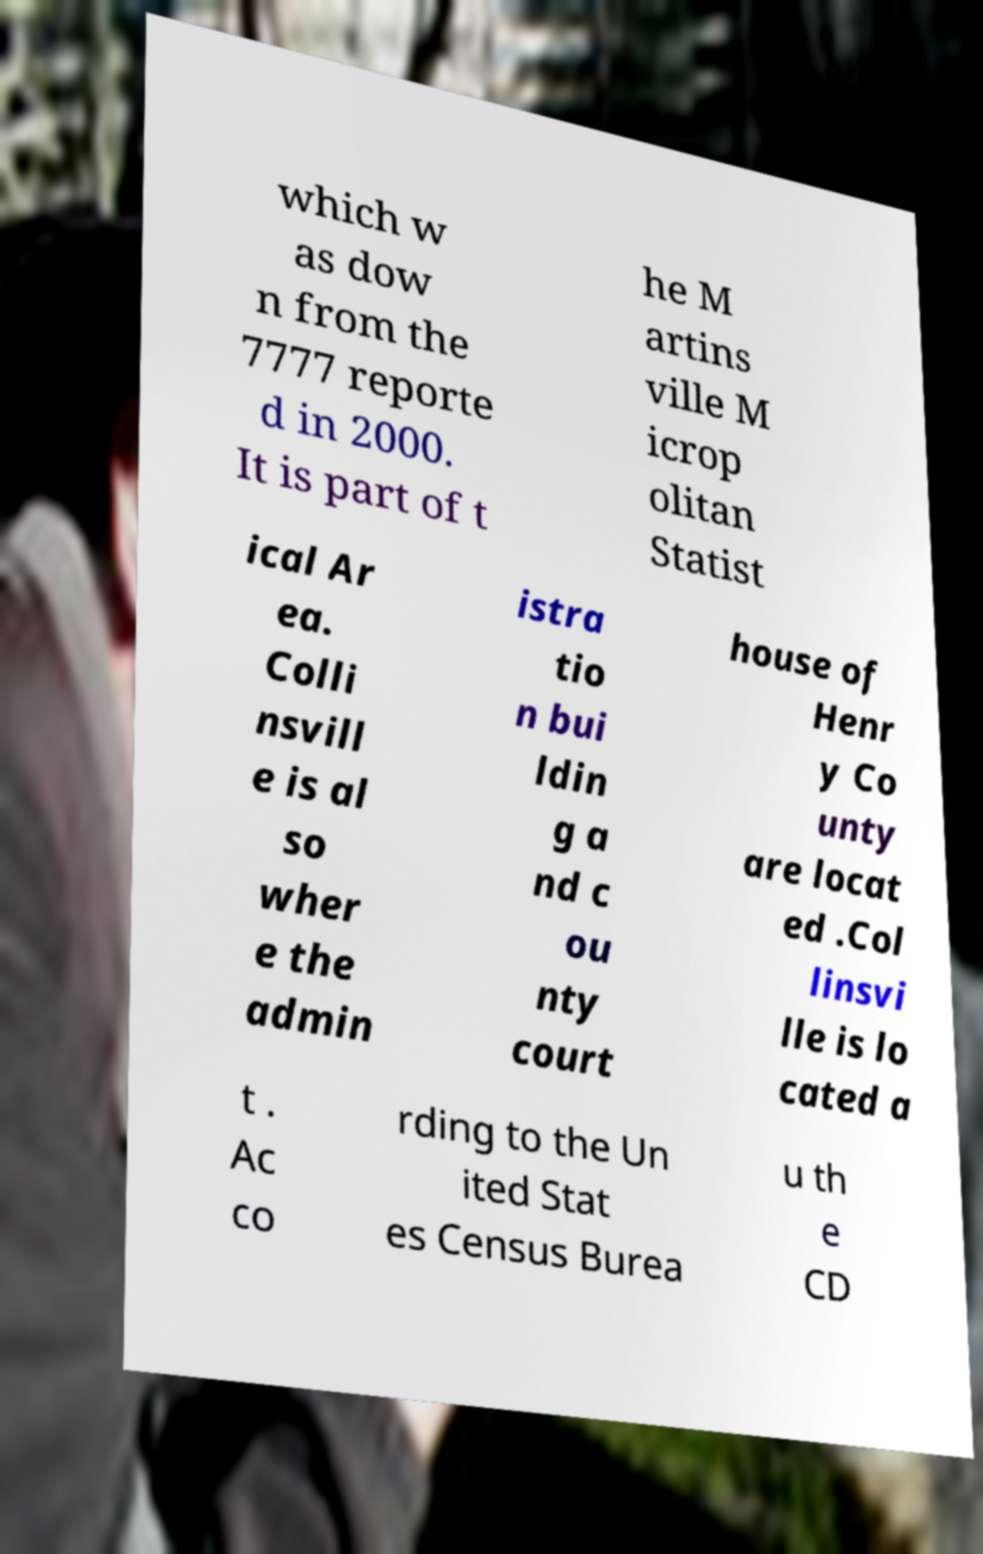Please identify and transcribe the text found in this image. which w as dow n from the 7777 reporte d in 2000. It is part of t he M artins ville M icrop olitan Statist ical Ar ea. Colli nsvill e is al so wher e the admin istra tio n bui ldin g a nd c ou nty court house of Henr y Co unty are locat ed .Col linsvi lle is lo cated a t . Ac co rding to the Un ited Stat es Census Burea u th e CD 